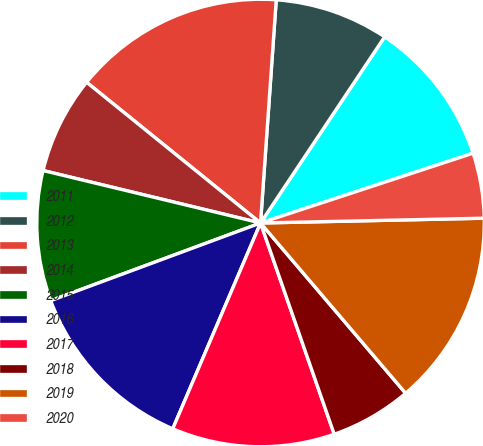Convert chart to OTSL. <chart><loc_0><loc_0><loc_500><loc_500><pie_chart><fcel>2011<fcel>2012<fcel>2013<fcel>2014<fcel>2015<fcel>2016<fcel>2017<fcel>2018<fcel>2019<fcel>2020<nl><fcel>10.59%<fcel>8.24%<fcel>15.29%<fcel>7.06%<fcel>9.41%<fcel>12.94%<fcel>11.76%<fcel>5.89%<fcel>14.11%<fcel>4.71%<nl></chart> 